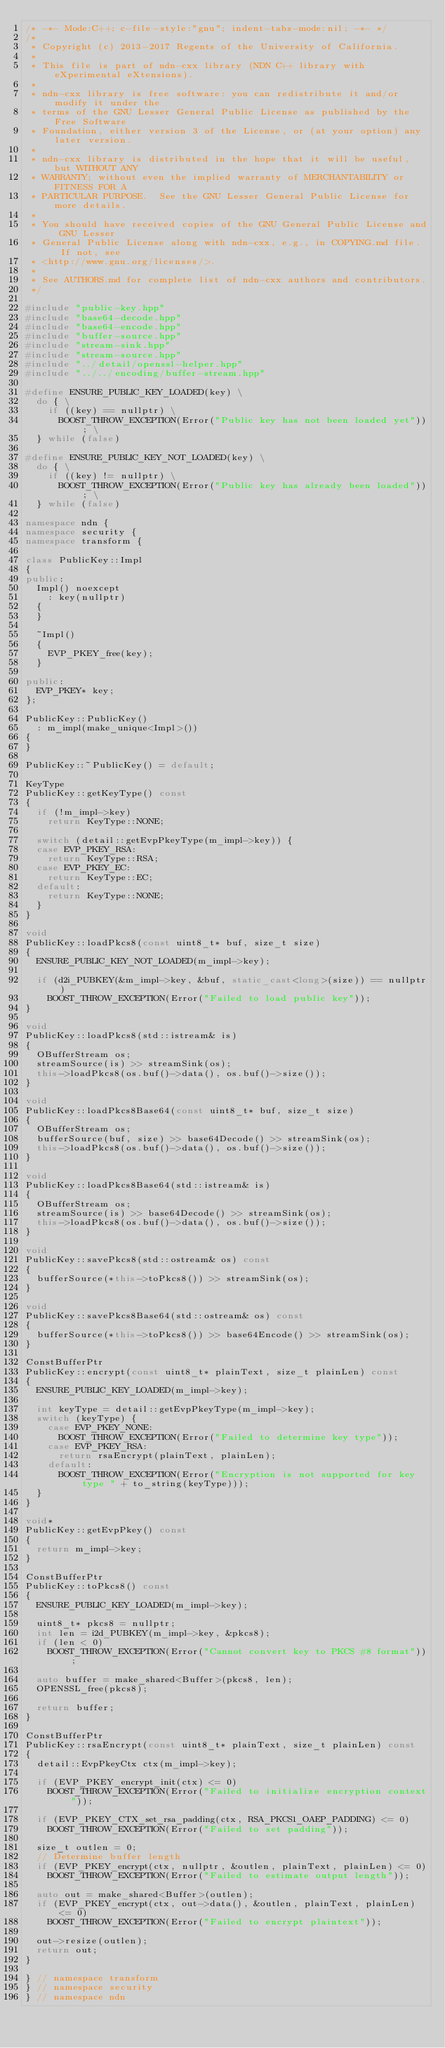Convert code to text. <code><loc_0><loc_0><loc_500><loc_500><_C++_>/* -*- Mode:C++; c-file-style:"gnu"; indent-tabs-mode:nil; -*- */
/*
 * Copyright (c) 2013-2017 Regents of the University of California.
 *
 * This file is part of ndn-cxx library (NDN C++ library with eXperimental eXtensions).
 *
 * ndn-cxx library is free software: you can redistribute it and/or modify it under the
 * terms of the GNU Lesser General Public License as published by the Free Software
 * Foundation, either version 3 of the License, or (at your option) any later version.
 *
 * ndn-cxx library is distributed in the hope that it will be useful, but WITHOUT ANY
 * WARRANTY; without even the implied warranty of MERCHANTABILITY or FITNESS FOR A
 * PARTICULAR PURPOSE.  See the GNU Lesser General Public License for more details.
 *
 * You should have received copies of the GNU General Public License and GNU Lesser
 * General Public License along with ndn-cxx, e.g., in COPYING.md file.  If not, see
 * <http://www.gnu.org/licenses/>.
 *
 * See AUTHORS.md for complete list of ndn-cxx authors and contributors.
 */

#include "public-key.hpp"
#include "base64-decode.hpp"
#include "base64-encode.hpp"
#include "buffer-source.hpp"
#include "stream-sink.hpp"
#include "stream-source.hpp"
#include "../detail/openssl-helper.hpp"
#include "../../encoding/buffer-stream.hpp"

#define ENSURE_PUBLIC_KEY_LOADED(key) \
  do { \
    if ((key) == nullptr) \
      BOOST_THROW_EXCEPTION(Error("Public key has not been loaded yet")); \
  } while (false)

#define ENSURE_PUBLIC_KEY_NOT_LOADED(key) \
  do { \
    if ((key) != nullptr) \
      BOOST_THROW_EXCEPTION(Error("Public key has already been loaded")); \
  } while (false)

namespace ndn {
namespace security {
namespace transform {

class PublicKey::Impl
{
public:
  Impl() noexcept
    : key(nullptr)
  {
  }

  ~Impl()
  {
    EVP_PKEY_free(key);
  }

public:
  EVP_PKEY* key;
};

PublicKey::PublicKey()
  : m_impl(make_unique<Impl>())
{
}

PublicKey::~PublicKey() = default;

KeyType
PublicKey::getKeyType() const
{
  if (!m_impl->key)
    return KeyType::NONE;

  switch (detail::getEvpPkeyType(m_impl->key)) {
  case EVP_PKEY_RSA:
    return KeyType::RSA;
  case EVP_PKEY_EC:
    return KeyType::EC;
  default:
    return KeyType::NONE;
  }
}

void
PublicKey::loadPkcs8(const uint8_t* buf, size_t size)
{
  ENSURE_PUBLIC_KEY_NOT_LOADED(m_impl->key);

  if (d2i_PUBKEY(&m_impl->key, &buf, static_cast<long>(size)) == nullptr)
    BOOST_THROW_EXCEPTION(Error("Failed to load public key"));
}

void
PublicKey::loadPkcs8(std::istream& is)
{
  OBufferStream os;
  streamSource(is) >> streamSink(os);
  this->loadPkcs8(os.buf()->data(), os.buf()->size());
}

void
PublicKey::loadPkcs8Base64(const uint8_t* buf, size_t size)
{
  OBufferStream os;
  bufferSource(buf, size) >> base64Decode() >> streamSink(os);
  this->loadPkcs8(os.buf()->data(), os.buf()->size());
}

void
PublicKey::loadPkcs8Base64(std::istream& is)
{
  OBufferStream os;
  streamSource(is) >> base64Decode() >> streamSink(os);
  this->loadPkcs8(os.buf()->data(), os.buf()->size());
}

void
PublicKey::savePkcs8(std::ostream& os) const
{
  bufferSource(*this->toPkcs8()) >> streamSink(os);
}

void
PublicKey::savePkcs8Base64(std::ostream& os) const
{
  bufferSource(*this->toPkcs8()) >> base64Encode() >> streamSink(os);
}

ConstBufferPtr
PublicKey::encrypt(const uint8_t* plainText, size_t plainLen) const
{
  ENSURE_PUBLIC_KEY_LOADED(m_impl->key);

  int keyType = detail::getEvpPkeyType(m_impl->key);
  switch (keyType) {
    case EVP_PKEY_NONE:
      BOOST_THROW_EXCEPTION(Error("Failed to determine key type"));
    case EVP_PKEY_RSA:
      return rsaEncrypt(plainText, plainLen);
    default:
      BOOST_THROW_EXCEPTION(Error("Encryption is not supported for key type " + to_string(keyType)));
  }
}

void*
PublicKey::getEvpPkey() const
{
  return m_impl->key;
}

ConstBufferPtr
PublicKey::toPkcs8() const
{
  ENSURE_PUBLIC_KEY_LOADED(m_impl->key);

  uint8_t* pkcs8 = nullptr;
  int len = i2d_PUBKEY(m_impl->key, &pkcs8);
  if (len < 0)
    BOOST_THROW_EXCEPTION(Error("Cannot convert key to PKCS #8 format"));

  auto buffer = make_shared<Buffer>(pkcs8, len);
  OPENSSL_free(pkcs8);

  return buffer;
}

ConstBufferPtr
PublicKey::rsaEncrypt(const uint8_t* plainText, size_t plainLen) const
{
  detail::EvpPkeyCtx ctx(m_impl->key);

  if (EVP_PKEY_encrypt_init(ctx) <= 0)
    BOOST_THROW_EXCEPTION(Error("Failed to initialize encryption context"));

  if (EVP_PKEY_CTX_set_rsa_padding(ctx, RSA_PKCS1_OAEP_PADDING) <= 0)
    BOOST_THROW_EXCEPTION(Error("Failed to set padding"));

  size_t outlen = 0;
  // Determine buffer length
  if (EVP_PKEY_encrypt(ctx, nullptr, &outlen, plainText, plainLen) <= 0)
    BOOST_THROW_EXCEPTION(Error("Failed to estimate output length"));

  auto out = make_shared<Buffer>(outlen);
  if (EVP_PKEY_encrypt(ctx, out->data(), &outlen, plainText, plainLen) <= 0)
    BOOST_THROW_EXCEPTION(Error("Failed to encrypt plaintext"));

  out->resize(outlen);
  return out;
}

} // namespace transform
} // namespace security
} // namespace ndn
</code> 